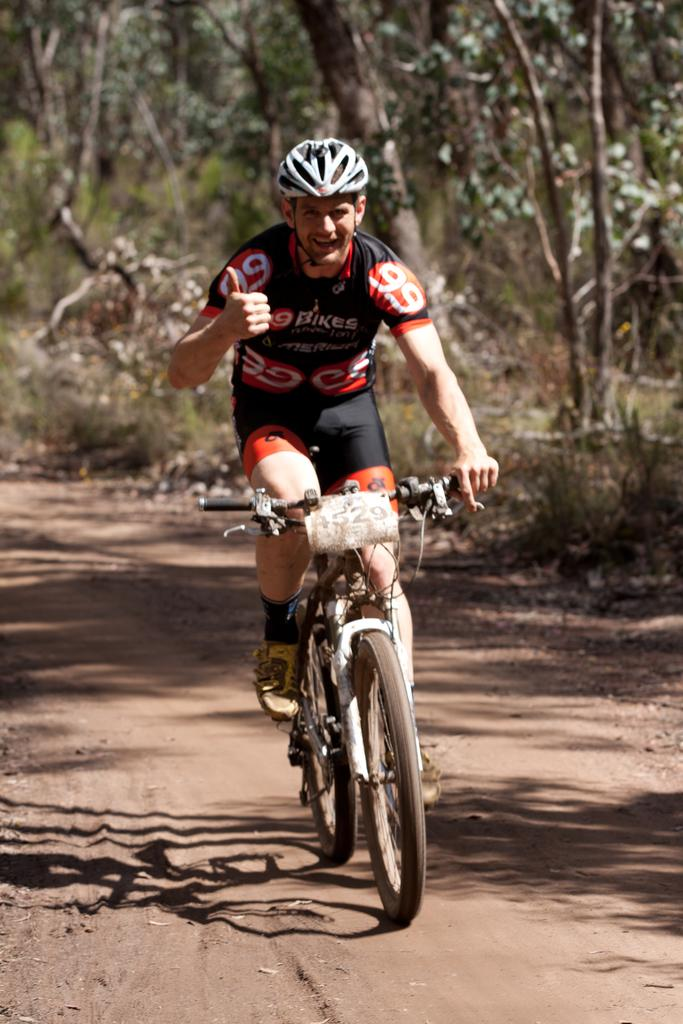Who is present in the image? There is a man in the image. What is the man wearing on his head? The man is wearing a helmet. What is the man doing in the image? The man is riding a bicycle. What is the position of the bicycle in the image? The bicycle is on the ground. What can be seen in the background of the image? There are trees in the background of the image. What color is the orange that the man is holding in the image? There is no orange present in the image; the man is riding a bicycle and wearing a helmet. What type of crime is the crook committing in the image? There is no crook or crime depicted in the image; it features a man riding a bicycle. 